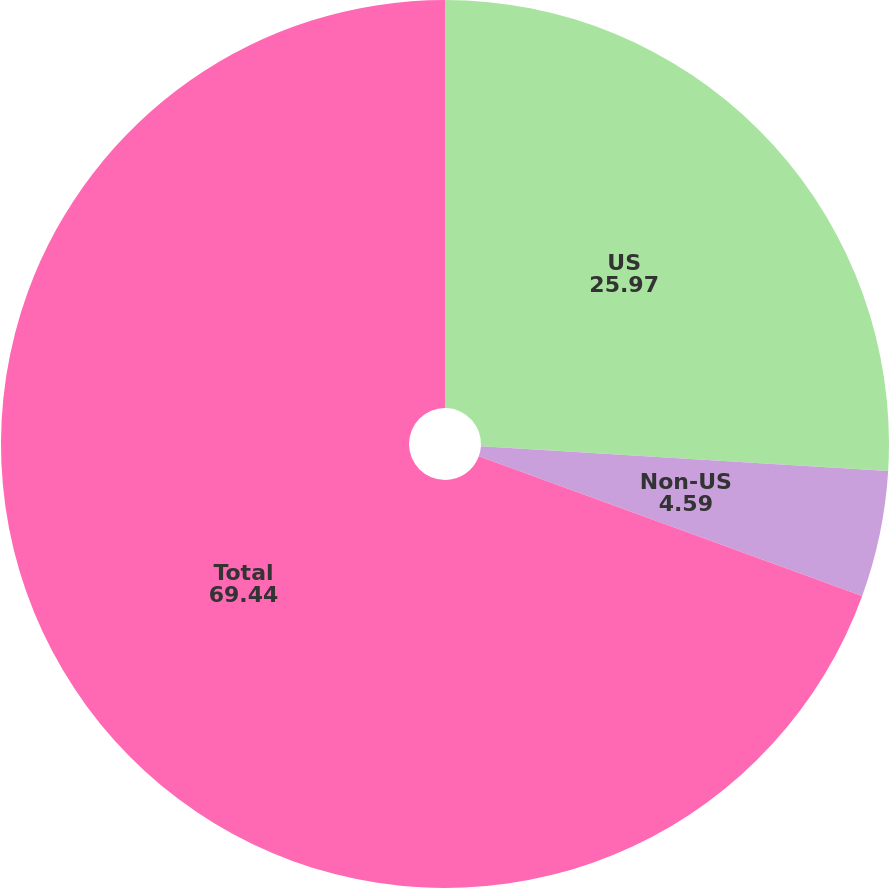Convert chart to OTSL. <chart><loc_0><loc_0><loc_500><loc_500><pie_chart><fcel>US<fcel>Non-US<fcel>Total<nl><fcel>25.97%<fcel>4.59%<fcel>69.44%<nl></chart> 